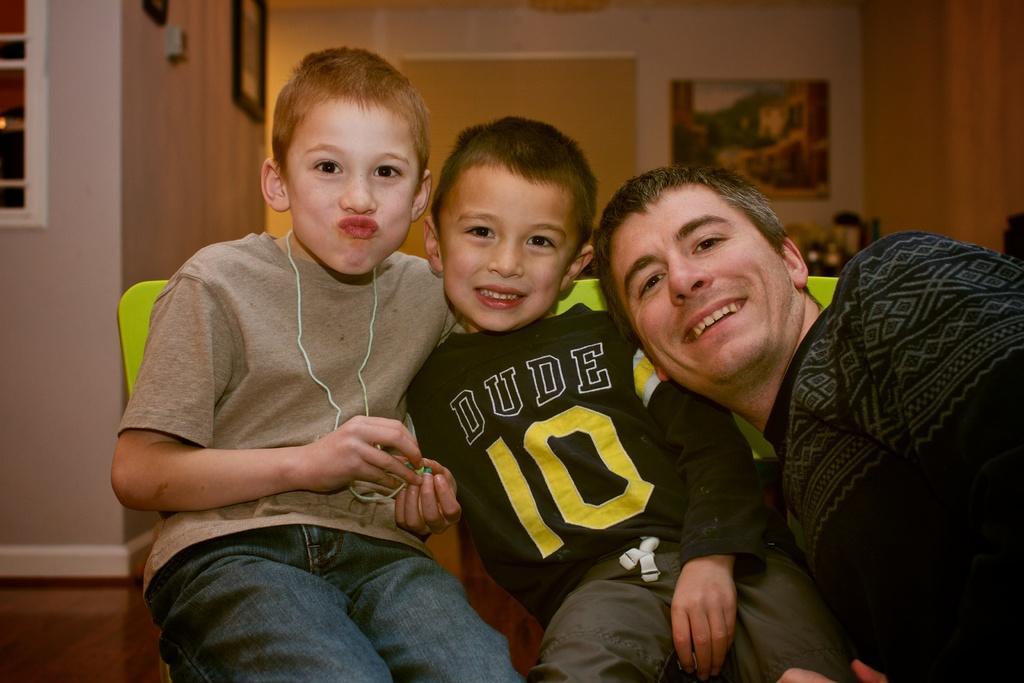Describe this image in one or two sentences. In this picture we can see the inside view of a building. Inside the building, there are three persons and some objects. Behind the three persons, there are photo frames attached to the wall. In the top left corner of the image, it looks like a window. 